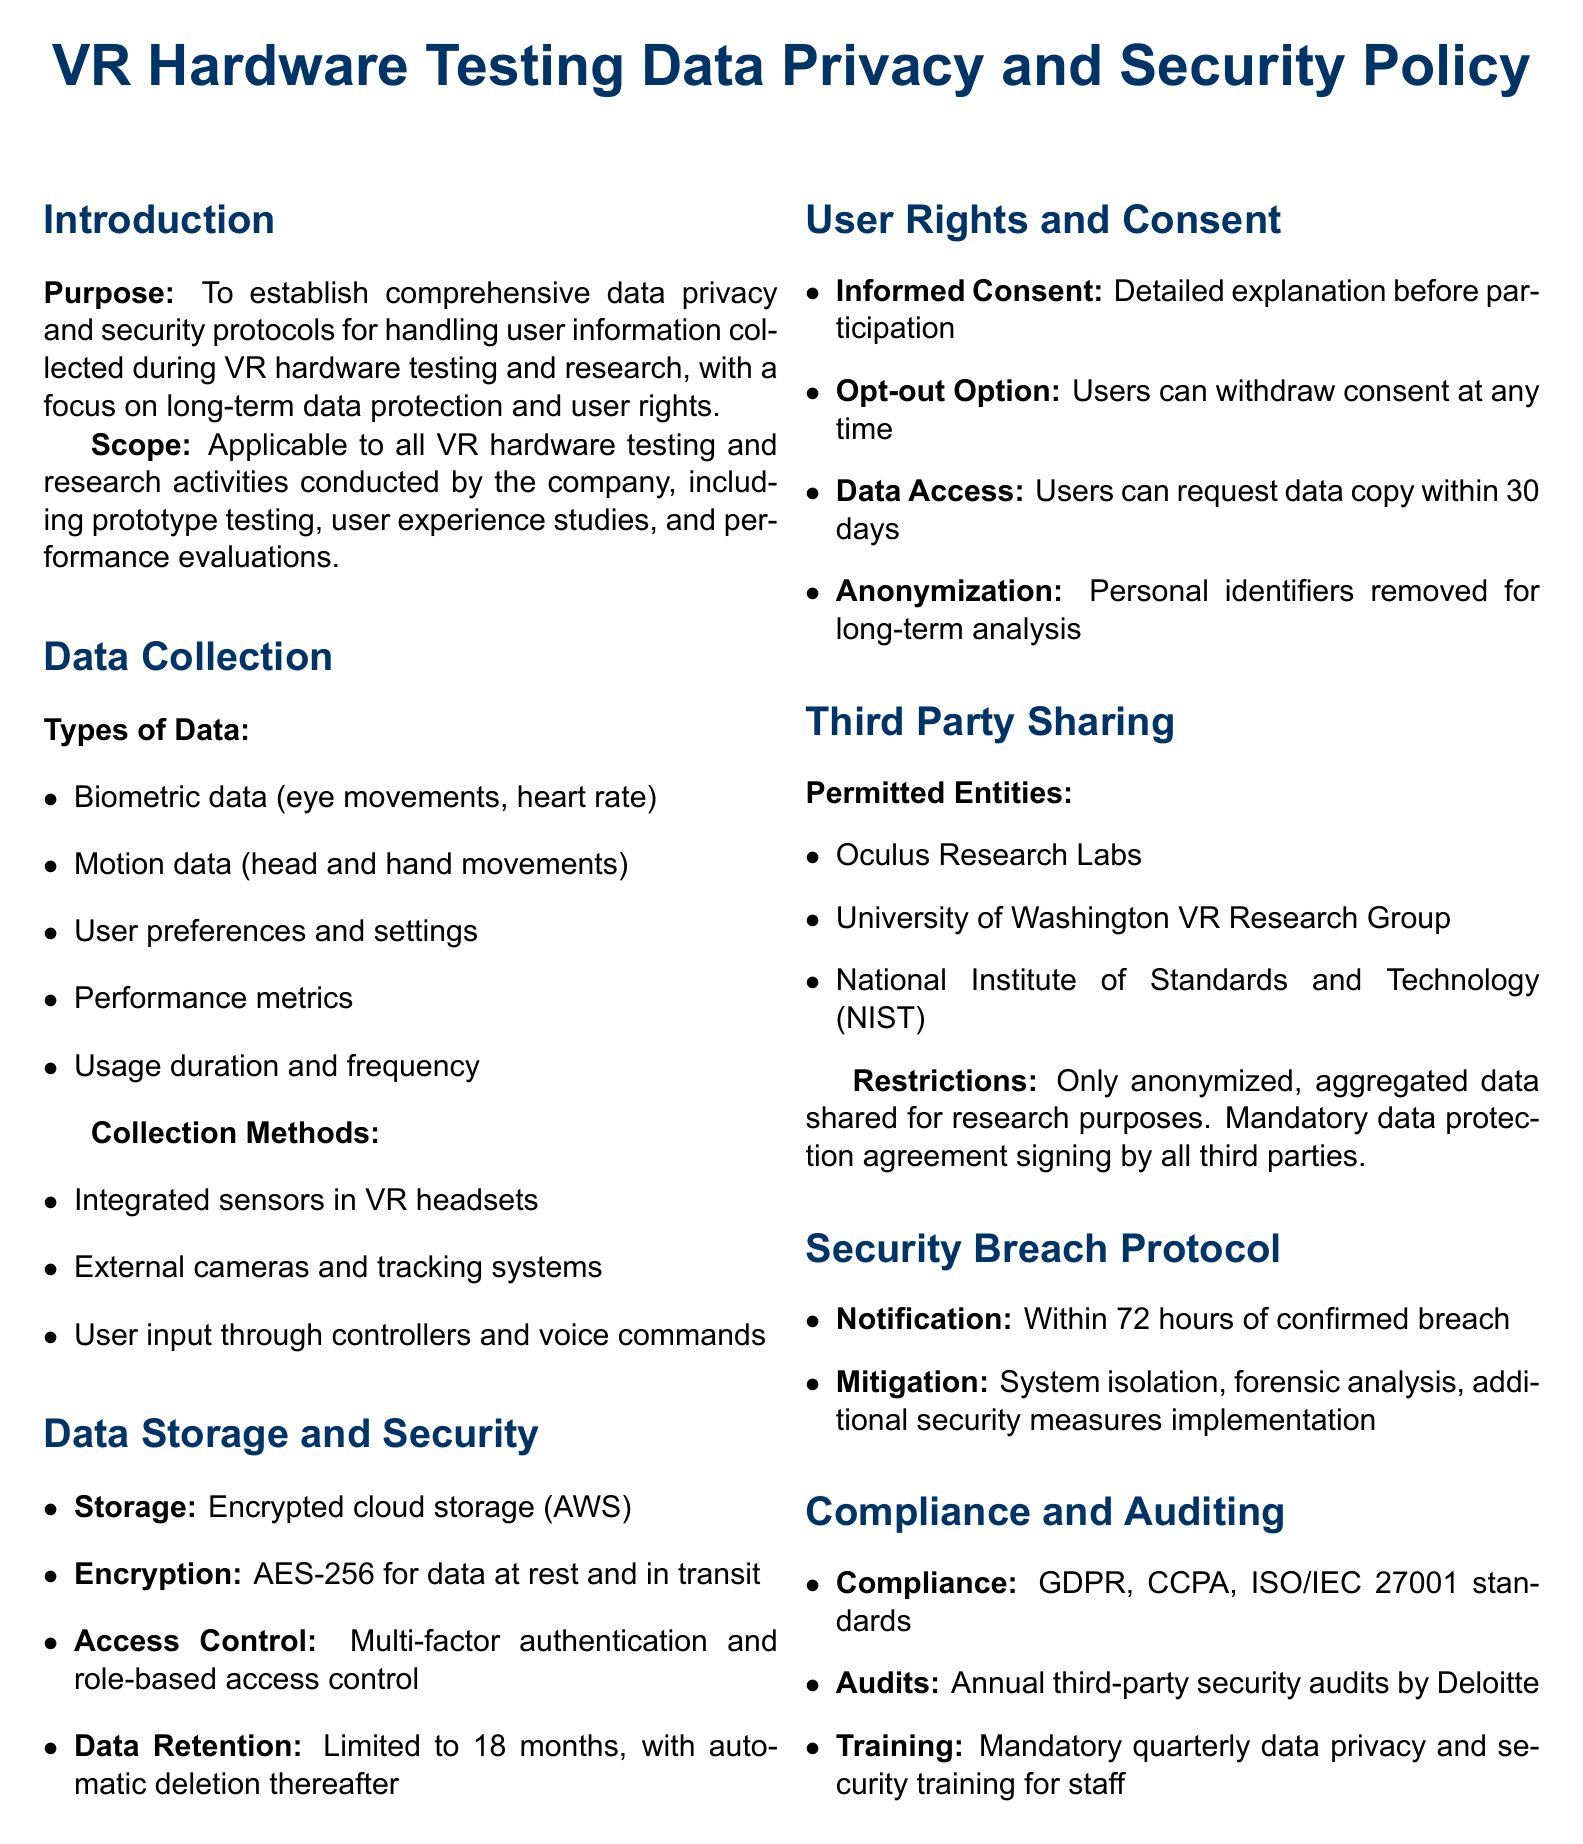What is the purpose of the policy? The purpose is to establish comprehensive data privacy and security protocols for handling user information collected during VR hardware testing and research.
Answer: To establish comprehensive data privacy and security protocols What types of data are collected? The types of data include biometric data, motion data, user preferences, performance metrics, and usage duration.
Answer: Biometric data, motion data, user preferences, performance metrics, usage duration What is the encryption standard used for data storage? The document specifies AES-256 for data at rest and in transit.
Answer: AES-256 What is the data retention period stated in the policy? The data retention period is limited to 18 months, with automatic deletion thereafter.
Answer: 18 months What entities are permitted to access the shared data? Permitted entities include Oculus Research Labs, University of Washington VR Research Group, and National Institute of Standards and Technology.
Answer: Oculus Research Labs, University of Washington VR Research Group, National Institute of Standards and Technology What happens within 72 hours of a confirmed security breach? The document mandates notification within 72 hours of a confirmed breach.
Answer: Notification Which regulatory standards does the policy comply with? The policy complies with GDPR, CCPA, and ISO/IEC 27001 standards.
Answer: GDPR, CCPA, ISO/IEC 27001 How often are security audits conducted? The audits are conducted annually by a third party.
Answer: Annually What type of training is mandatory for staff? The policy requires mandatory quarterly data privacy and security training for staff.
Answer: Quarterly data privacy and security training 